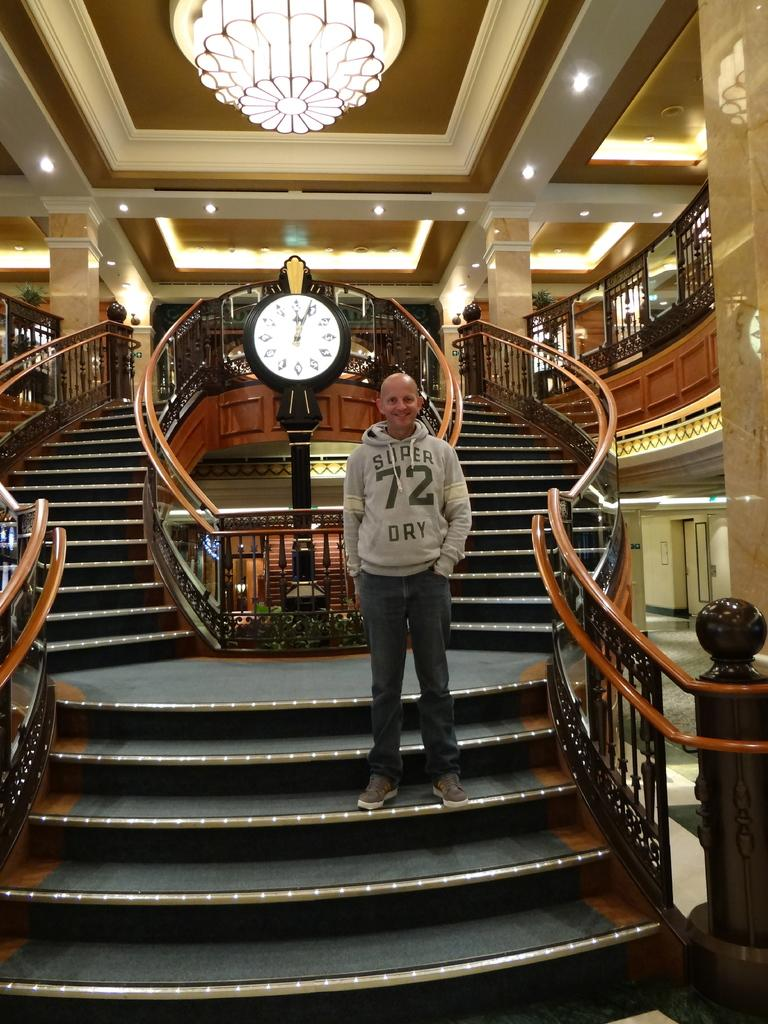Provide a one-sentence caption for the provided image. Standing on an amazing staircase the man wears a top saying 72. 